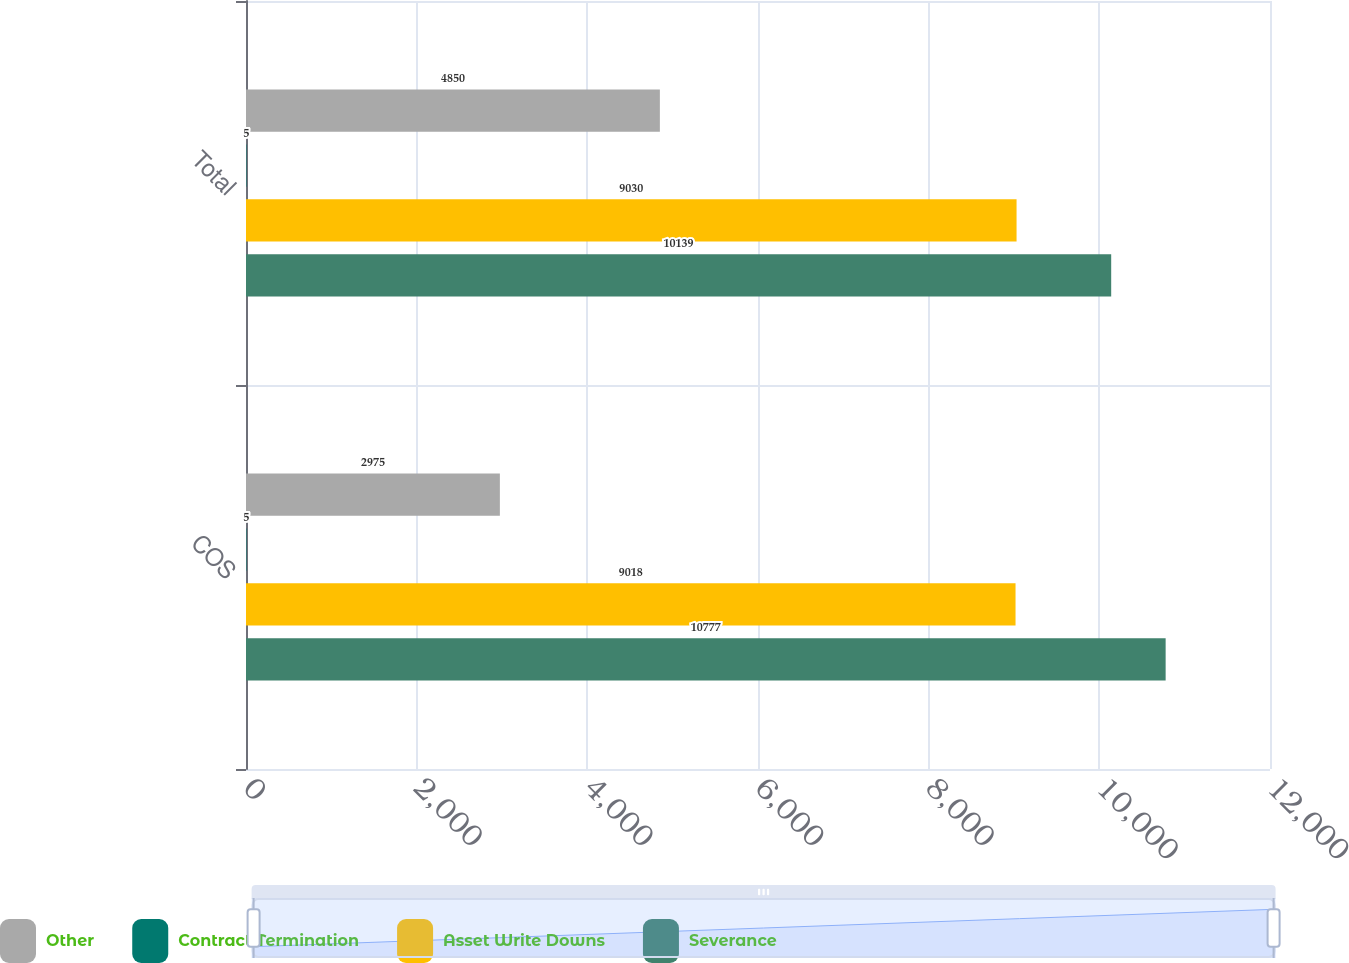<chart> <loc_0><loc_0><loc_500><loc_500><stacked_bar_chart><ecel><fcel>COS<fcel>Total<nl><fcel>Other<fcel>2975<fcel>4850<nl><fcel>Contract Termination<fcel>5<fcel>5<nl><fcel>Asset Write Downs<fcel>9018<fcel>9030<nl><fcel>Severance<fcel>10777<fcel>10139<nl></chart> 